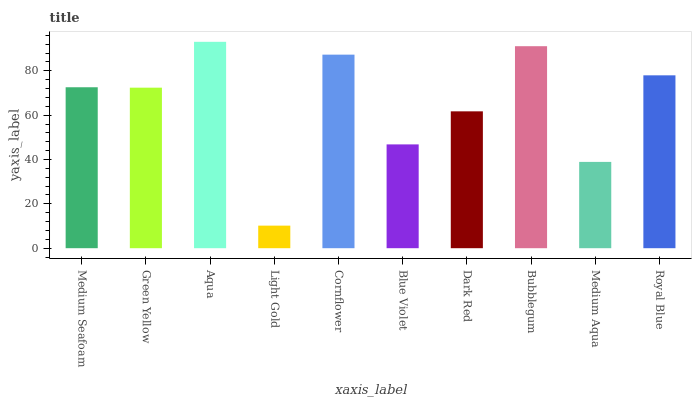Is Light Gold the minimum?
Answer yes or no. Yes. Is Aqua the maximum?
Answer yes or no. Yes. Is Green Yellow the minimum?
Answer yes or no. No. Is Green Yellow the maximum?
Answer yes or no. No. Is Medium Seafoam greater than Green Yellow?
Answer yes or no. Yes. Is Green Yellow less than Medium Seafoam?
Answer yes or no. Yes. Is Green Yellow greater than Medium Seafoam?
Answer yes or no. No. Is Medium Seafoam less than Green Yellow?
Answer yes or no. No. Is Medium Seafoam the high median?
Answer yes or no. Yes. Is Green Yellow the low median?
Answer yes or no. Yes. Is Medium Aqua the high median?
Answer yes or no. No. Is Light Gold the low median?
Answer yes or no. No. 